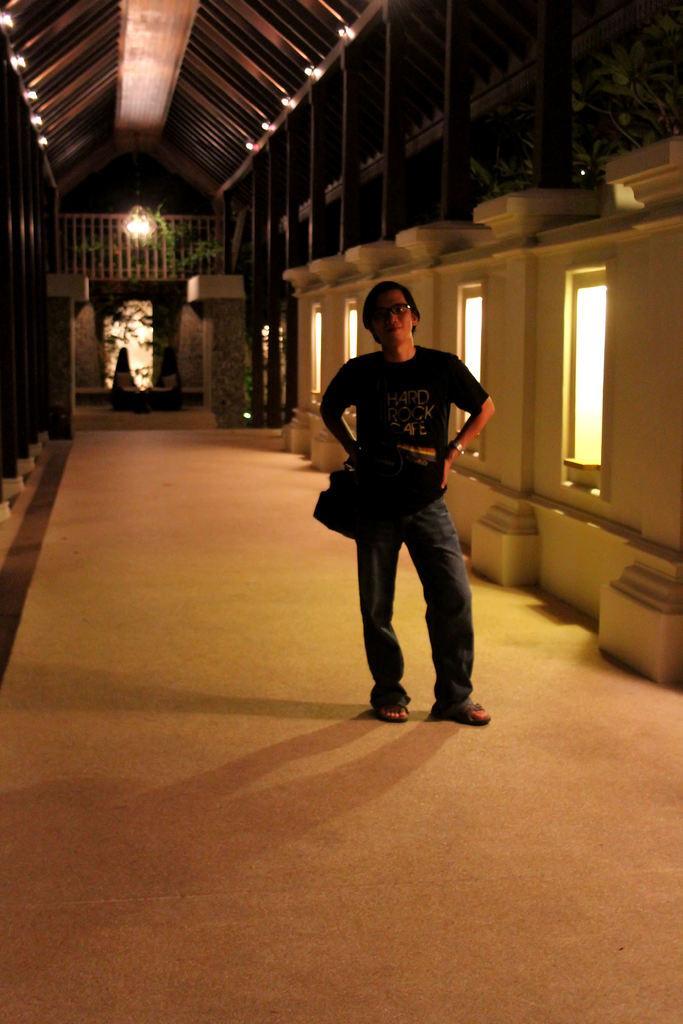Could you give a brief overview of what you see in this image? In this picture we can see a person wore a spectacle and standing on the floor and at the back of this person we can see windows, lights, pillars, fence, plants and some objects. 